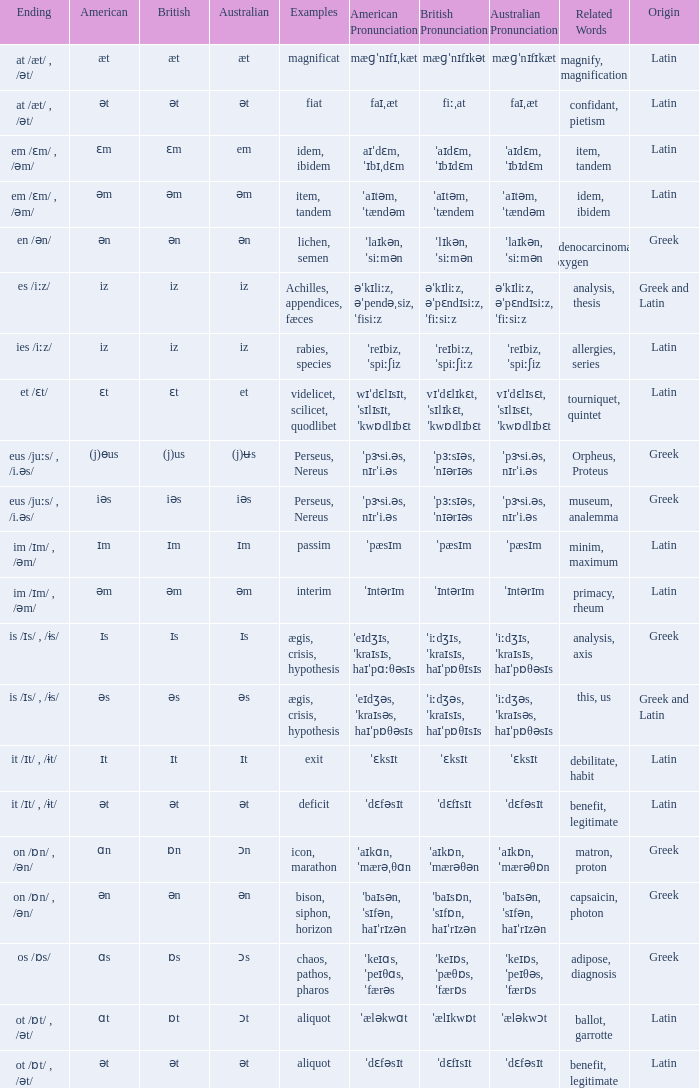Which Australian has British of ɒs? Ɔs. 